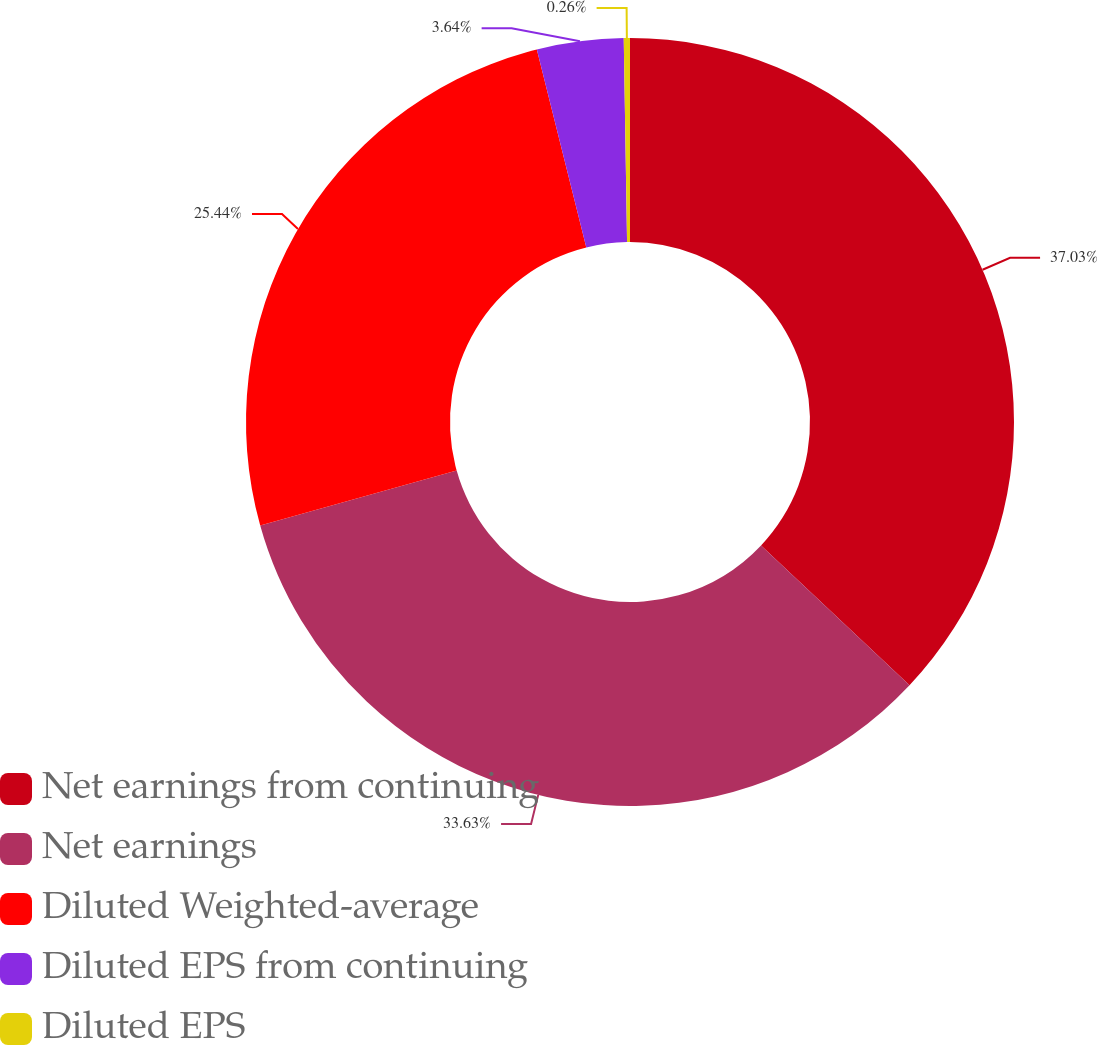<chart> <loc_0><loc_0><loc_500><loc_500><pie_chart><fcel>Net earnings from continuing<fcel>Net earnings<fcel>Diluted Weighted-average<fcel>Diluted EPS from continuing<fcel>Diluted EPS<nl><fcel>37.02%<fcel>33.63%<fcel>25.44%<fcel>3.64%<fcel>0.26%<nl></chart> 